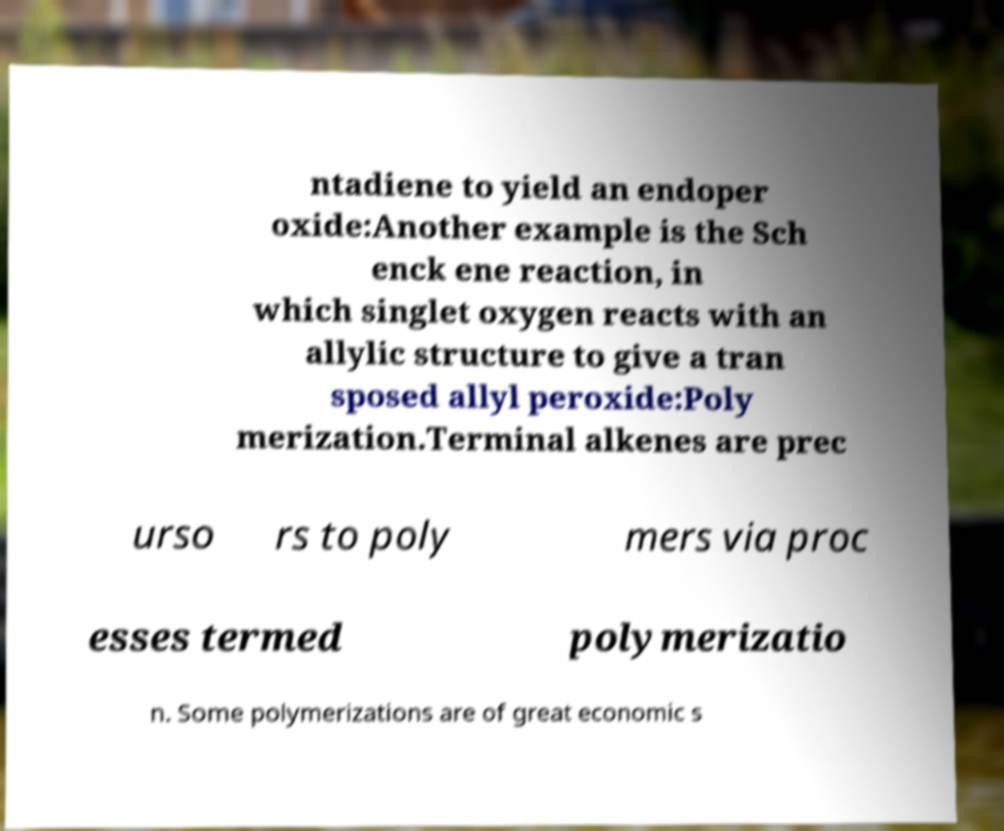Please identify and transcribe the text found in this image. ntadiene to yield an endoper oxide:Another example is the Sch enck ene reaction, in which singlet oxygen reacts with an allylic structure to give a tran sposed allyl peroxide:Poly merization.Terminal alkenes are prec urso rs to poly mers via proc esses termed polymerizatio n. Some polymerizations are of great economic s 